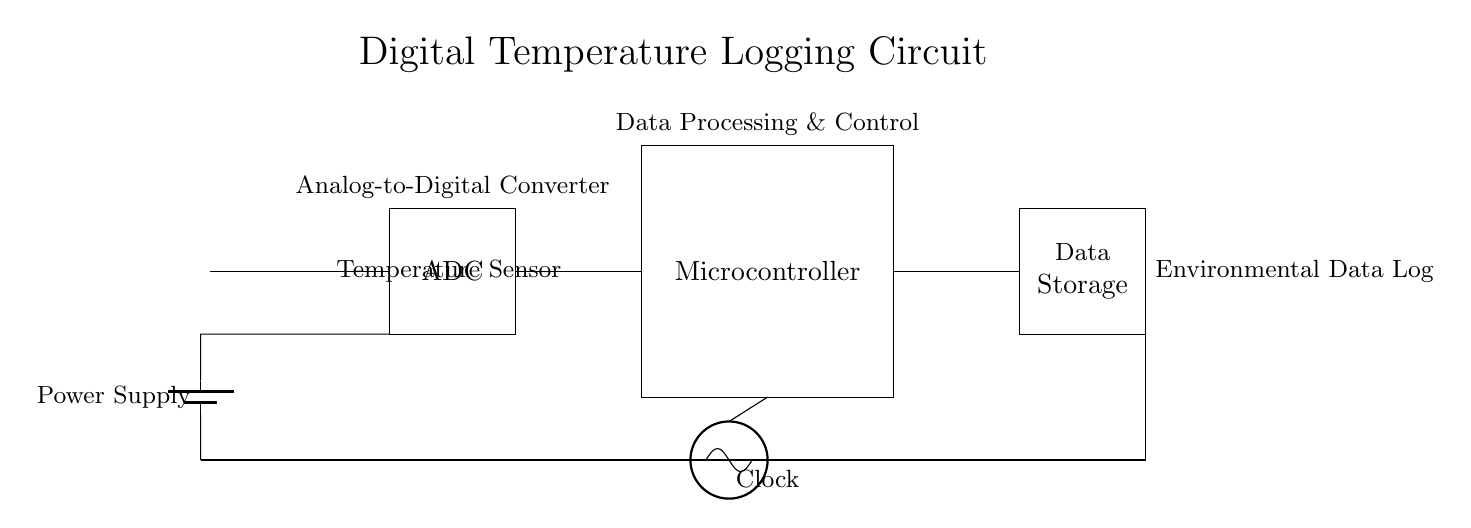What is the component used for measuring temperature? The component used for measuring temperature is the thermistor, indicated in the circuit as the temperature sensor.
Answer: thermistor What processes the analog signal from the temperature sensor? The analog signal from the temperature sensor is processed by the ADC, or Analog-to-Digital Converter, which converts the analog temperature readings into digital format for further processing.
Answer: ADC What is the primary function of the microcontroller in this circuit? The primary function of the microcontroller is to process the data received from the ADC, control operations, and manage communication with the data storage unit.
Answer: Data processing & control How is power supplied to the entire circuit? Power is supplied to the circuit via the battery, which connects to the circuit and provides the necessary voltage to all components in the system.
Answer: Battery What is the purpose of data storage in this circuit? The purpose of data storage is to hold the environmental data collected over time, allowing for tracking and analysis of temperature changes and conditions.
Answer: Environmental data log Which component provides timing in the circuit? The component that provides timing in the circuit is the clock, depicted as an oscillator in the diagram, which ensures that data processing occurs in a timed manner.
Answer: Clock What type of circuit does this setup represent? This setup represents a digital temperature logging circuit, which specifically involves the conversion of analog temperature readings to digital data for tracking environmental conditions.
Answer: Digital temperature logging circuit 